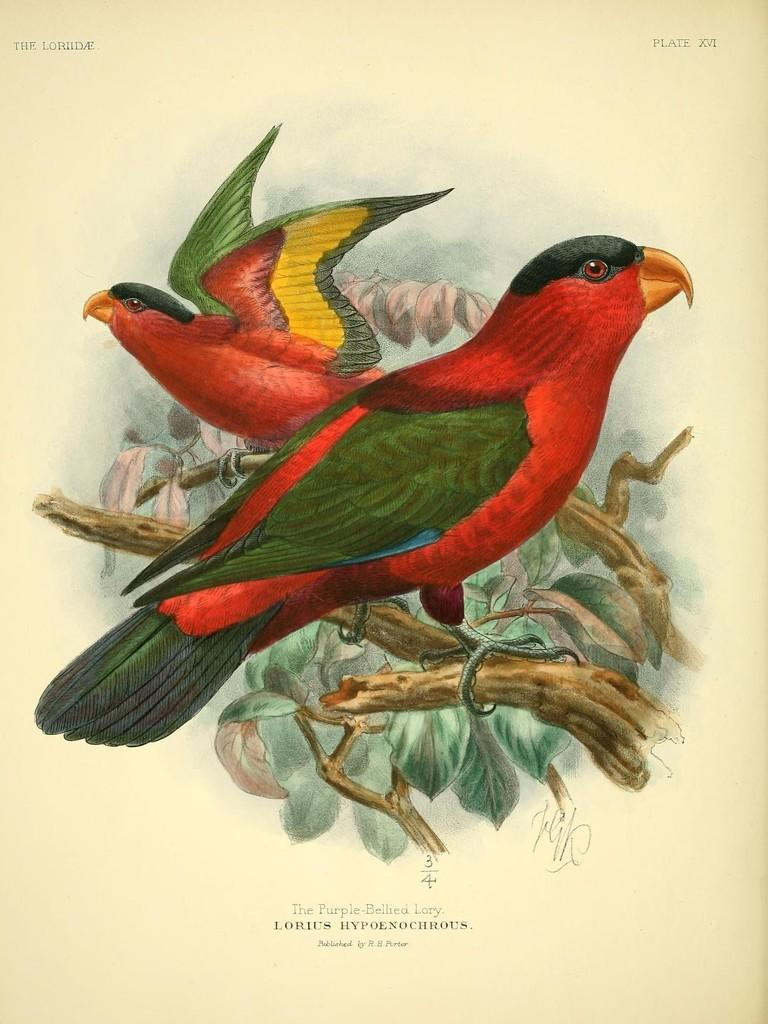What is depicted on the paper in the image? The paper contains a painting of two birds. What are the birds doing in the painting? The birds are standing on branches in the painting. Is there any text on the paper? Yes, there is writing on the paper. What time of day is depicted in the painting of the birds? The time of day is not depicted in the painting of the birds; it only shows the birds standing on branches. 